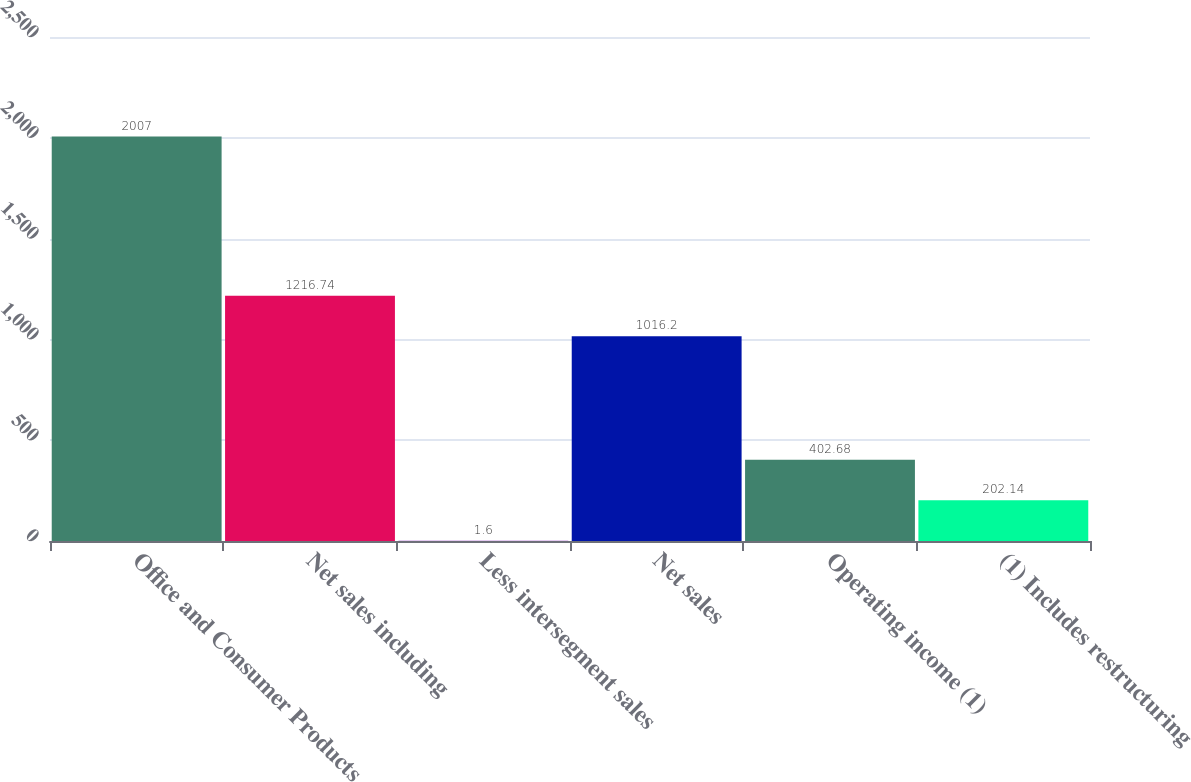Convert chart. <chart><loc_0><loc_0><loc_500><loc_500><bar_chart><fcel>Office and Consumer Products<fcel>Net sales including<fcel>Less intersegment sales<fcel>Net sales<fcel>Operating income (1)<fcel>(1) Includes restructuring<nl><fcel>2007<fcel>1216.74<fcel>1.6<fcel>1016.2<fcel>402.68<fcel>202.14<nl></chart> 